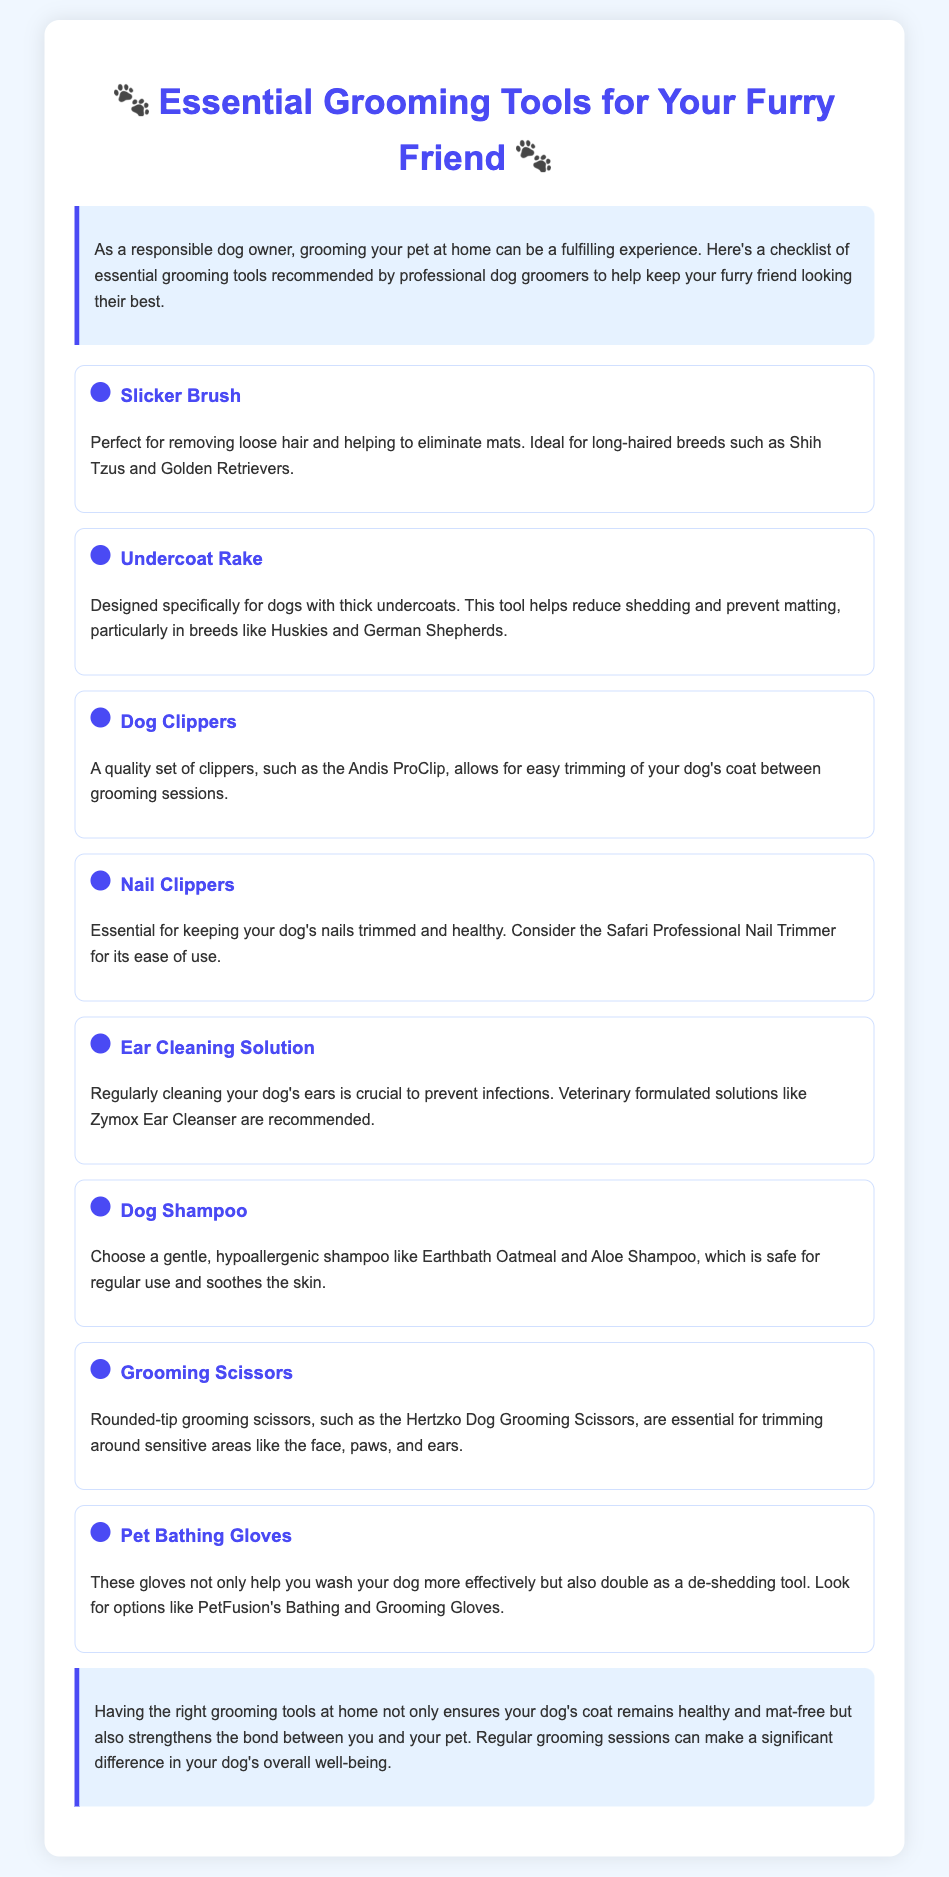What is the title of the document? The title is prominently displayed at the top of the document, stating the recommended tools for dog owners.
Answer: Essential Grooming Tools for Your Furry Friend How many grooming tools are listed in the document? The document features a checklist that enumerates the tools, showing a total of eight items.
Answer: Eight Which tool is recommended for removing loose hair? The specific tool for this purpose is clearly described, stating its primary function for hair removal.
Answer: Slicker Brush What is the recommended ear cleaning solution? The document provides a specific brand of ear cleaning solution that is veterinary formulated.
Answer: Zymox Ear Cleanser Which type of scissors is essential for trimming around sensitive areas? The content details a particular style of scissors, emphasizing their rounded-tip design.
Answer: Rounded-tip grooming scissors What is the function of pet bathing gloves? The document explains the dual purpose of these gloves for washing and grooming your pet.
Answer: Washing and de-shedding Which shampoo is recommended for regular use? A specific shampoo brand is named for its gentle and hypoallergenic properties.
Answer: Earthbath Oatmeal and Aloe Shampoo Which dog breeds are ideal candidates for using an undercoat rake? The document mentions specific breeds that benefit from this grooming tool, highlighting characteristics of their coats.
Answer: Huskies and German Shepherds 